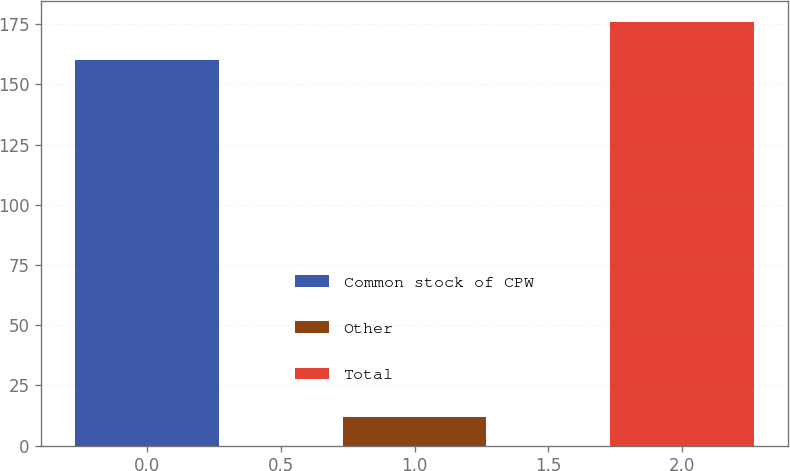Convert chart. <chart><loc_0><loc_0><loc_500><loc_500><bar_chart><fcel>Common stock of CPW<fcel>Other<fcel>Total<nl><fcel>160<fcel>12<fcel>176<nl></chart> 